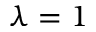<formula> <loc_0><loc_0><loc_500><loc_500>\lambda = 1</formula> 